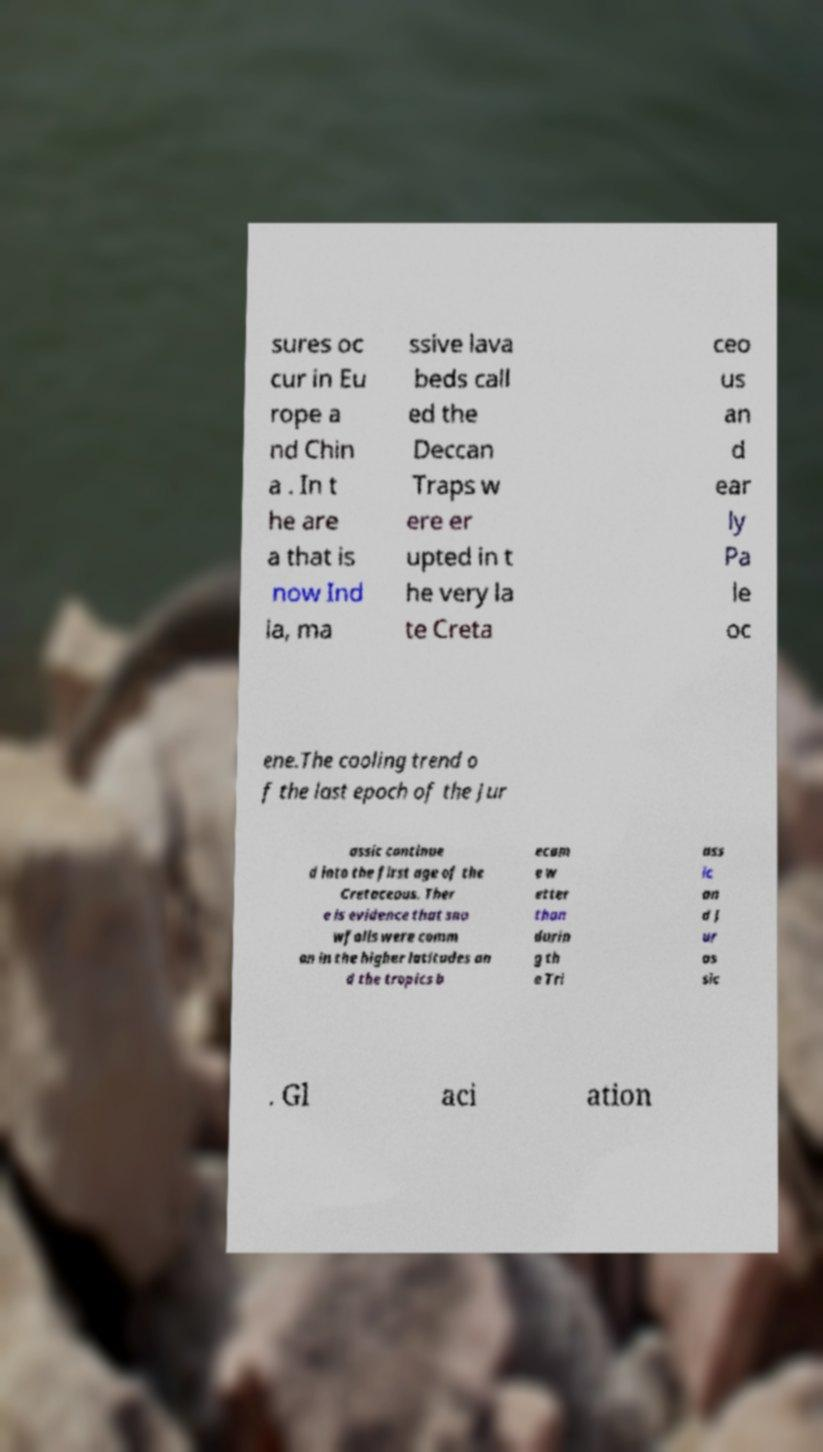Can you accurately transcribe the text from the provided image for me? sures oc cur in Eu rope a nd Chin a . In t he are a that is now Ind ia, ma ssive lava beds call ed the Deccan Traps w ere er upted in t he very la te Creta ceo us an d ear ly Pa le oc ene.The cooling trend o f the last epoch of the Jur assic continue d into the first age of the Cretaceous. Ther e is evidence that sno wfalls were comm on in the higher latitudes an d the tropics b ecam e w etter than durin g th e Tri ass ic an d J ur as sic . Gl aci ation 